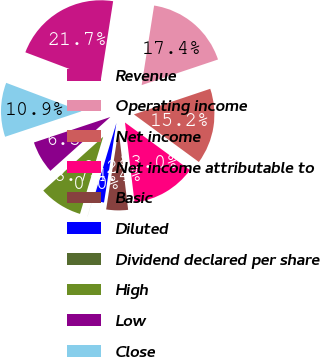<chart> <loc_0><loc_0><loc_500><loc_500><pie_chart><fcel>Revenue<fcel>Operating income<fcel>Net income<fcel>Net income attributable to<fcel>Basic<fcel>Diluted<fcel>Dividend declared per share<fcel>High<fcel>Low<fcel>Close<nl><fcel>21.72%<fcel>17.38%<fcel>15.21%<fcel>13.04%<fcel>4.36%<fcel>2.18%<fcel>0.01%<fcel>8.7%<fcel>6.53%<fcel>10.87%<nl></chart> 